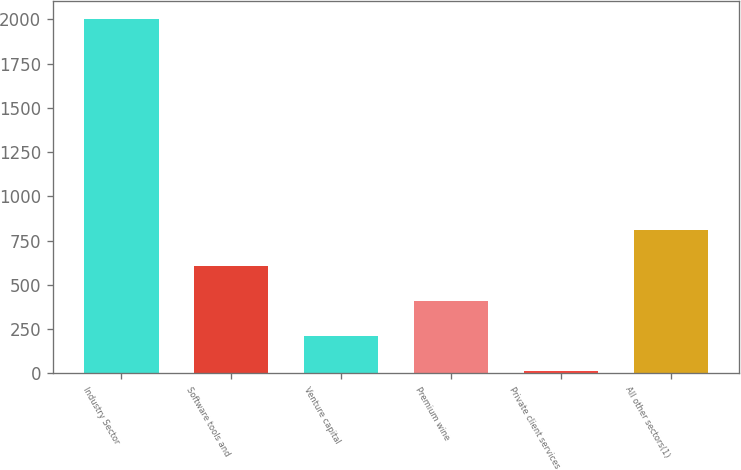Convert chart to OTSL. <chart><loc_0><loc_0><loc_500><loc_500><bar_chart><fcel>Industry Sector<fcel>Software tools and<fcel>Venture capital<fcel>Premium wine<fcel>Private client services<fcel>All other sectors(1)<nl><fcel>2004<fcel>609.04<fcel>210.48<fcel>409.76<fcel>11.2<fcel>808.32<nl></chart> 